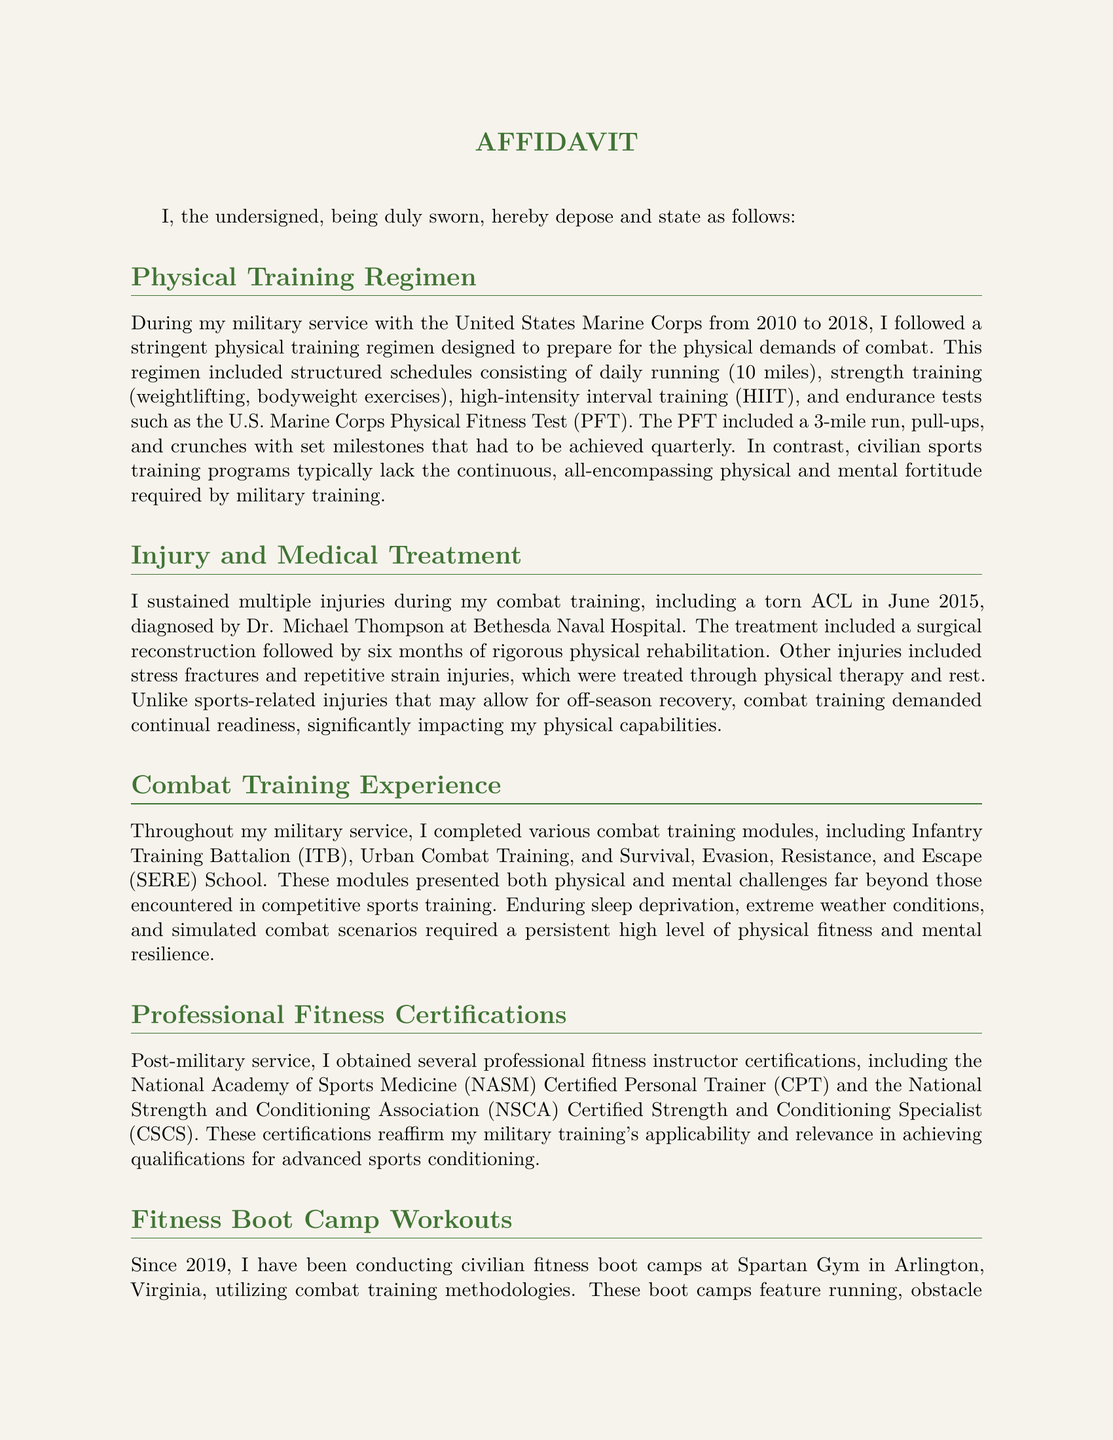What period did the military service cover? The document states that military service was from 2010 to 2018.
Answer: 2010 to 2018 What injury was sustained in June 2015? The document specifies a torn ACL diagnosed by Dr. Michael Thompson.
Answer: Torn ACL Who diagnosed the injury at Bethesda Naval Hospital? The document names Dr. Michael Thompson as the diagnosing physician.
Answer: Dr. Michael Thompson What is one type of certification obtained post-military service? The document lists the NASM Certified Personal Trainer as one certification.
Answer: NASM Certified Personal Trainer How long did rehabilitation last after the ACL surgery? The document indicates that rehabilitation lasted six months.
Answer: Six months What type of challenges are included in combat training compared to sports? The document describes enduring sleep deprivation and extreme weather conditions as challenges.
Answer: Sleep deprivation and extreme weather conditions What is the name of the gym where boot camps are conducted? The document mentions Spartan Gym in Arlington, Virginia as the location of boot camps.
Answer: Spartan Gym How many injuries are mentioned in the Affidavit? The document enumerates multiple injuries without specifying an exact count, but includes torn ACL, stress fractures, and repetitive strain injuries.
Answer: Multiple injuries What is the focus of the fitness boot camps? The document states the boot camps utilize combat training methodologies.
Answer: Combat training methodologies 